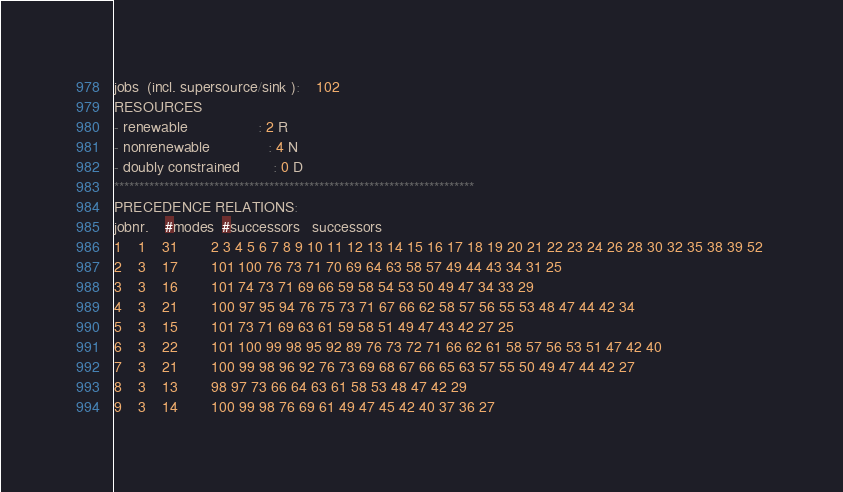<code> <loc_0><loc_0><loc_500><loc_500><_ObjectiveC_>jobs  (incl. supersource/sink ):	102
RESOURCES
- renewable                 : 2 R
- nonrenewable              : 4 N
- doubly constrained        : 0 D
************************************************************************
PRECEDENCE RELATIONS:
jobnr.    #modes  #successors   successors
1	1	31		2 3 4 5 6 7 8 9 10 11 12 13 14 15 16 17 18 19 20 21 22 23 24 26 28 30 32 35 38 39 52 
2	3	17		101 100 76 73 71 70 69 64 63 58 57 49 44 43 34 31 25 
3	3	16		101 74 73 71 69 66 59 58 54 53 50 49 47 34 33 29 
4	3	21		100 97 95 94 76 75 73 71 67 66 62 58 57 56 55 53 48 47 44 42 34 
5	3	15		101 73 71 69 63 61 59 58 51 49 47 43 42 27 25 
6	3	22		101 100 99 98 95 92 89 76 73 72 71 66 62 61 58 57 56 53 51 47 42 40 
7	3	21		100 99 98 96 92 76 73 69 68 67 66 65 63 57 55 50 49 47 44 42 27 
8	3	13		98 97 73 66 64 63 61 58 53 48 47 42 29 
9	3	14		100 99 98 76 69 61 49 47 45 42 40 37 36 27 </code> 